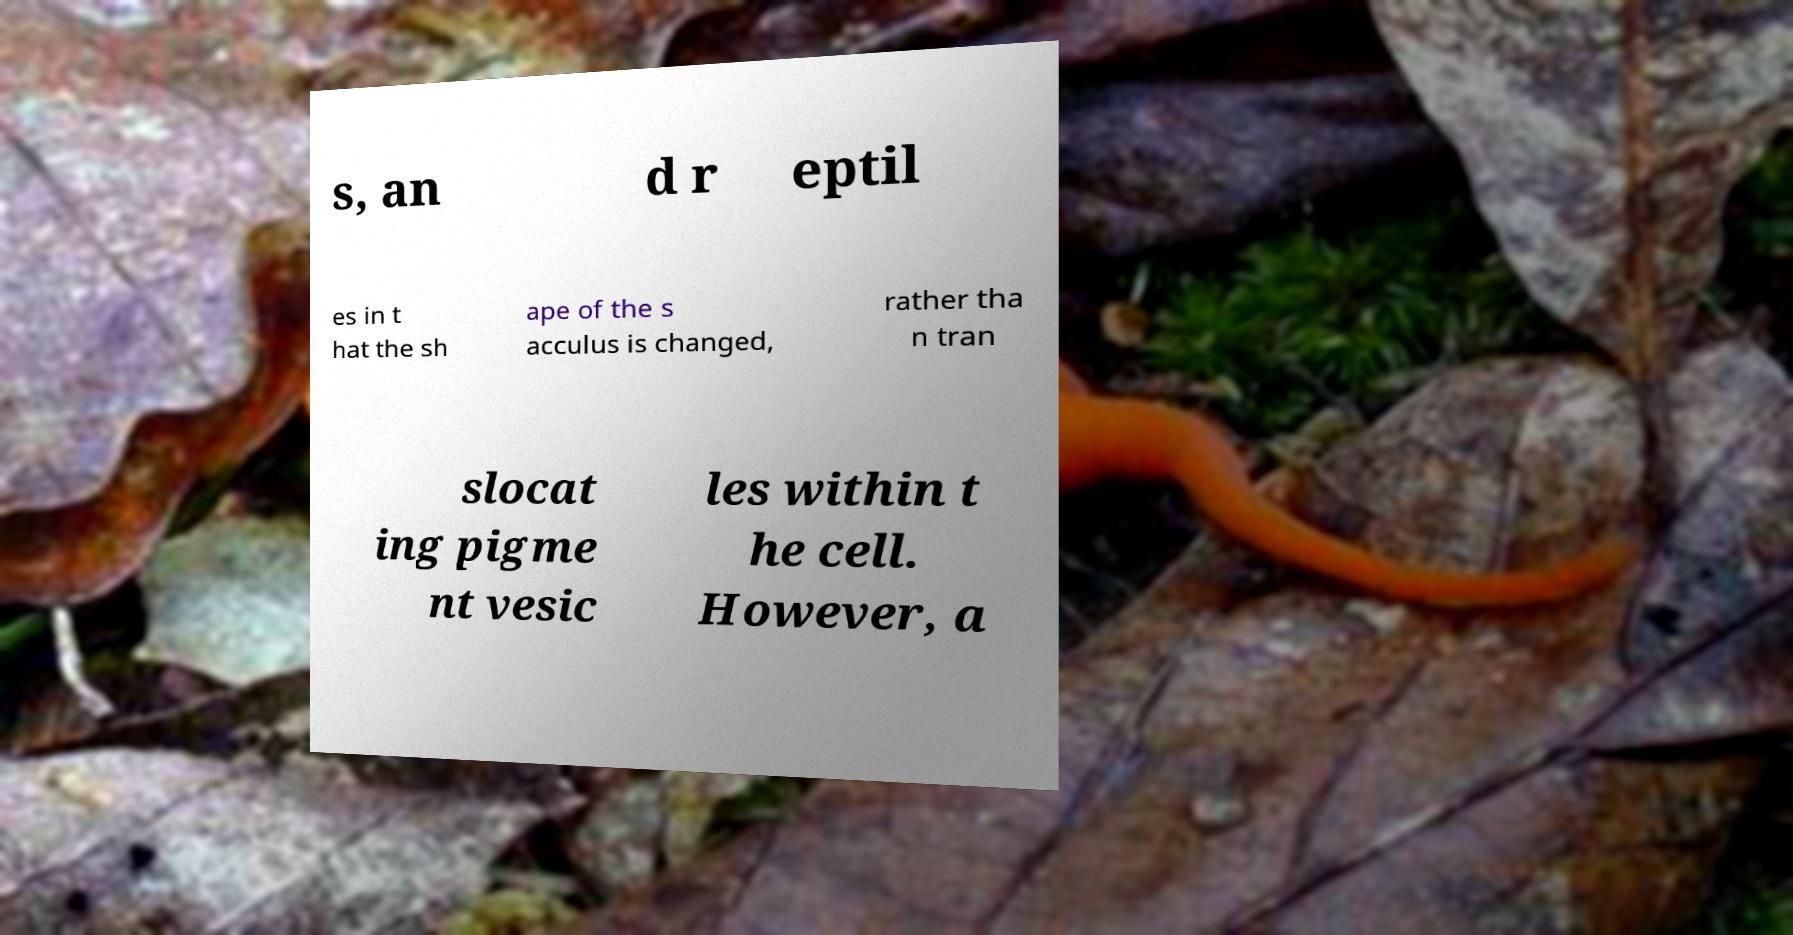Can you read and provide the text displayed in the image?This photo seems to have some interesting text. Can you extract and type it out for me? s, an d r eptil es in t hat the sh ape of the s acculus is changed, rather tha n tran slocat ing pigme nt vesic les within t he cell. However, a 